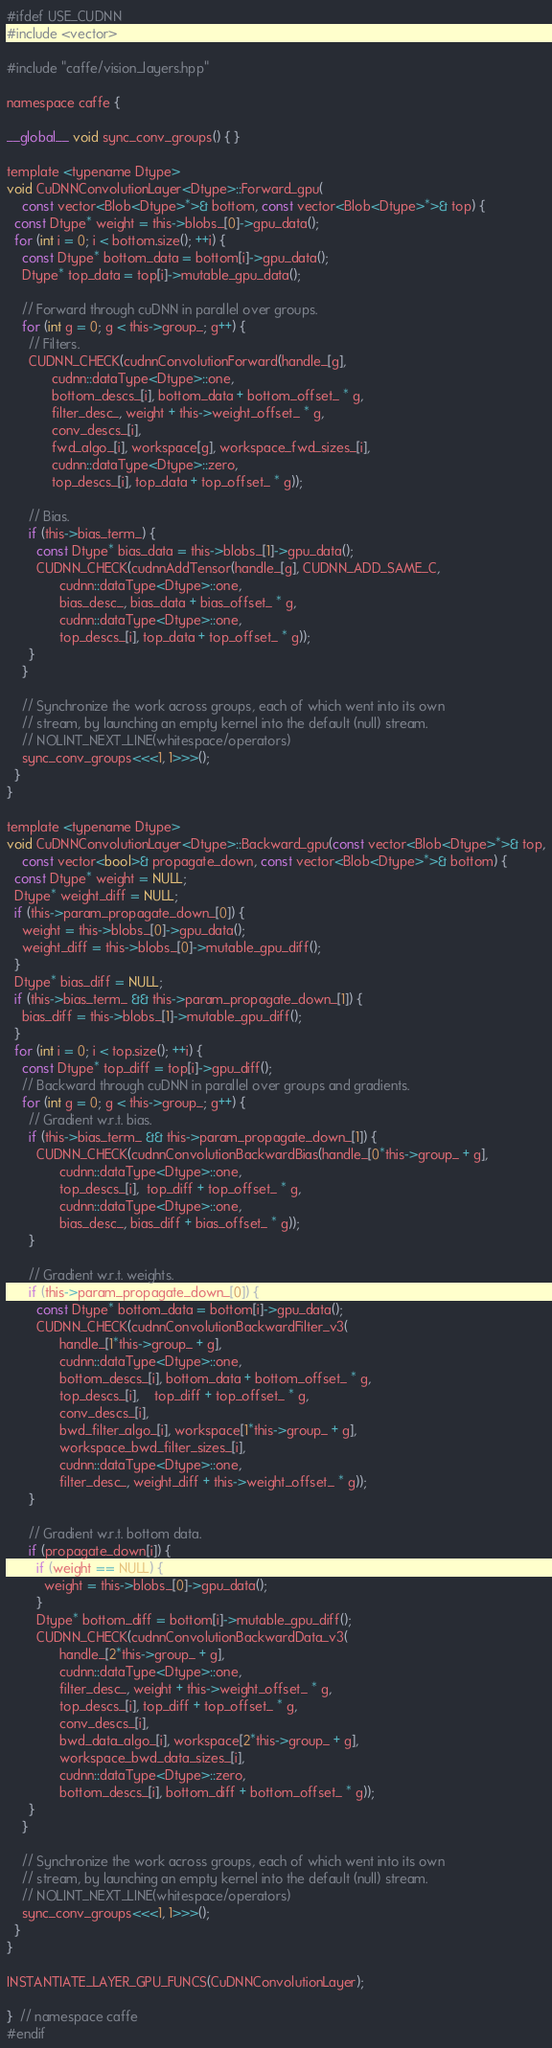Convert code to text. <code><loc_0><loc_0><loc_500><loc_500><_Cuda_>#ifdef USE_CUDNN
#include <vector>

#include "caffe/vision_layers.hpp"

namespace caffe {

__global__ void sync_conv_groups() { }

template <typename Dtype>
void CuDNNConvolutionLayer<Dtype>::Forward_gpu(
    const vector<Blob<Dtype>*>& bottom, const vector<Blob<Dtype>*>& top) {
  const Dtype* weight = this->blobs_[0]->gpu_data();
  for (int i = 0; i < bottom.size(); ++i) {
    const Dtype* bottom_data = bottom[i]->gpu_data();
    Dtype* top_data = top[i]->mutable_gpu_data();

    // Forward through cuDNN in parallel over groups.
    for (int g = 0; g < this->group_; g++) {
      // Filters.
      CUDNN_CHECK(cudnnConvolutionForward(handle_[g],
            cudnn::dataType<Dtype>::one,
            bottom_descs_[i], bottom_data + bottom_offset_ * g,
            filter_desc_, weight + this->weight_offset_ * g,
            conv_descs_[i],
            fwd_algo_[i], workspace[g], workspace_fwd_sizes_[i],
            cudnn::dataType<Dtype>::zero,
            top_descs_[i], top_data + top_offset_ * g));

      // Bias.
      if (this->bias_term_) {
        const Dtype* bias_data = this->blobs_[1]->gpu_data();
        CUDNN_CHECK(cudnnAddTensor(handle_[g], CUDNN_ADD_SAME_C,
              cudnn::dataType<Dtype>::one,
              bias_desc_, bias_data + bias_offset_ * g,
              cudnn::dataType<Dtype>::one,
              top_descs_[i], top_data + top_offset_ * g));
      }
    }

    // Synchronize the work across groups, each of which went into its own
    // stream, by launching an empty kernel into the default (null) stream.
    // NOLINT_NEXT_LINE(whitespace/operators)
    sync_conv_groups<<<1, 1>>>();
  }
}

template <typename Dtype>
void CuDNNConvolutionLayer<Dtype>::Backward_gpu(const vector<Blob<Dtype>*>& top,
    const vector<bool>& propagate_down, const vector<Blob<Dtype>*>& bottom) {
  const Dtype* weight = NULL;
  Dtype* weight_diff = NULL;
  if (this->param_propagate_down_[0]) {
    weight = this->blobs_[0]->gpu_data();
    weight_diff = this->blobs_[0]->mutable_gpu_diff();
  }
  Dtype* bias_diff = NULL;
  if (this->bias_term_ && this->param_propagate_down_[1]) {
    bias_diff = this->blobs_[1]->mutable_gpu_diff();
  }
  for (int i = 0; i < top.size(); ++i) {
    const Dtype* top_diff = top[i]->gpu_diff();
    // Backward through cuDNN in parallel over groups and gradients.
    for (int g = 0; g < this->group_; g++) {
      // Gradient w.r.t. bias.
      if (this->bias_term_ && this->param_propagate_down_[1]) {
        CUDNN_CHECK(cudnnConvolutionBackwardBias(handle_[0*this->group_ + g],
              cudnn::dataType<Dtype>::one,
              top_descs_[i],  top_diff + top_offset_ * g,
              cudnn::dataType<Dtype>::one,
              bias_desc_, bias_diff + bias_offset_ * g));
      }

      // Gradient w.r.t. weights.
      if (this->param_propagate_down_[0]) {
        const Dtype* bottom_data = bottom[i]->gpu_data();
        CUDNN_CHECK(cudnnConvolutionBackwardFilter_v3(
              handle_[1*this->group_ + g],
              cudnn::dataType<Dtype>::one,
              bottom_descs_[i], bottom_data + bottom_offset_ * g,
              top_descs_[i],    top_diff + top_offset_ * g,
              conv_descs_[i],
              bwd_filter_algo_[i], workspace[1*this->group_ + g],
              workspace_bwd_filter_sizes_[i],
              cudnn::dataType<Dtype>::one,
              filter_desc_, weight_diff + this->weight_offset_ * g));
      }

      // Gradient w.r.t. bottom data.
      if (propagate_down[i]) {
        if (weight == NULL) {
          weight = this->blobs_[0]->gpu_data();
        }
        Dtype* bottom_diff = bottom[i]->mutable_gpu_diff();
        CUDNN_CHECK(cudnnConvolutionBackwardData_v3(
              handle_[2*this->group_ + g],
              cudnn::dataType<Dtype>::one,
              filter_desc_, weight + this->weight_offset_ * g,
              top_descs_[i], top_diff + top_offset_ * g,
              conv_descs_[i],
              bwd_data_algo_[i], workspace[2*this->group_ + g],
              workspace_bwd_data_sizes_[i],
              cudnn::dataType<Dtype>::zero,
              bottom_descs_[i], bottom_diff + bottom_offset_ * g));
      }
    }

    // Synchronize the work across groups, each of which went into its own
    // stream, by launching an empty kernel into the default (null) stream.
    // NOLINT_NEXT_LINE(whitespace/operators)
    sync_conv_groups<<<1, 1>>>();
  }
}

INSTANTIATE_LAYER_GPU_FUNCS(CuDNNConvolutionLayer);

}  // namespace caffe
#endif
</code> 